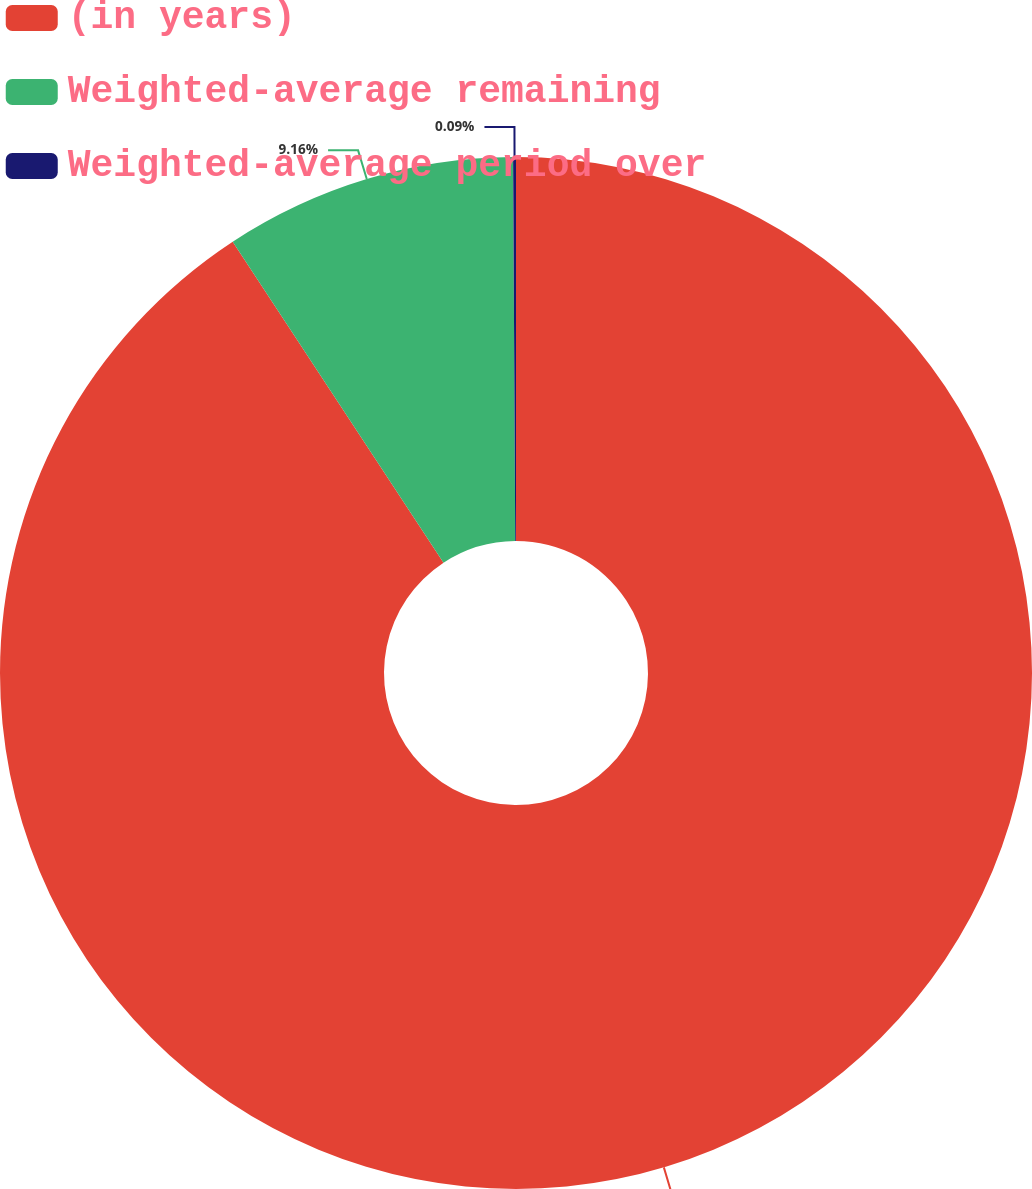Convert chart to OTSL. <chart><loc_0><loc_0><loc_500><loc_500><pie_chart><fcel>(in years)<fcel>Weighted-average remaining<fcel>Weighted-average period over<nl><fcel>90.75%<fcel>9.16%<fcel>0.09%<nl></chart> 